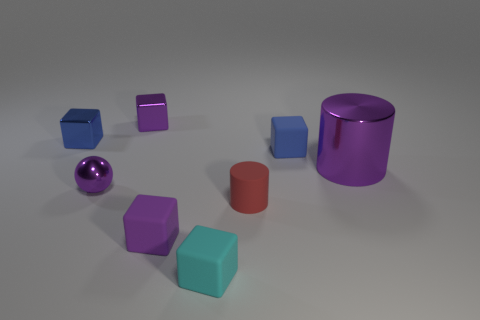Is there anything else that has the same size as the purple cylinder?
Provide a short and direct response. No. Are there any blue shiny blocks of the same size as the red cylinder?
Make the answer very short. Yes. Is the number of tiny purple metallic spheres less than the number of brown rubber blocks?
Make the answer very short. No. What number of balls are purple rubber things or blue metallic things?
Offer a very short reply. 0. How many other small rubber cylinders have the same color as the tiny rubber cylinder?
Offer a terse response. 0. There is a purple object that is right of the tiny sphere and in front of the purple shiny cylinder; what size is it?
Provide a succinct answer. Small. Are there fewer tiny red matte things behind the tiny blue shiny cube than tiny blue matte things?
Keep it short and to the point. Yes. Does the big cylinder have the same material as the tiny red object?
Offer a terse response. No. What number of objects are cyan matte cubes or blue shiny objects?
Provide a succinct answer. 2. How many other small objects have the same material as the cyan object?
Make the answer very short. 3. 